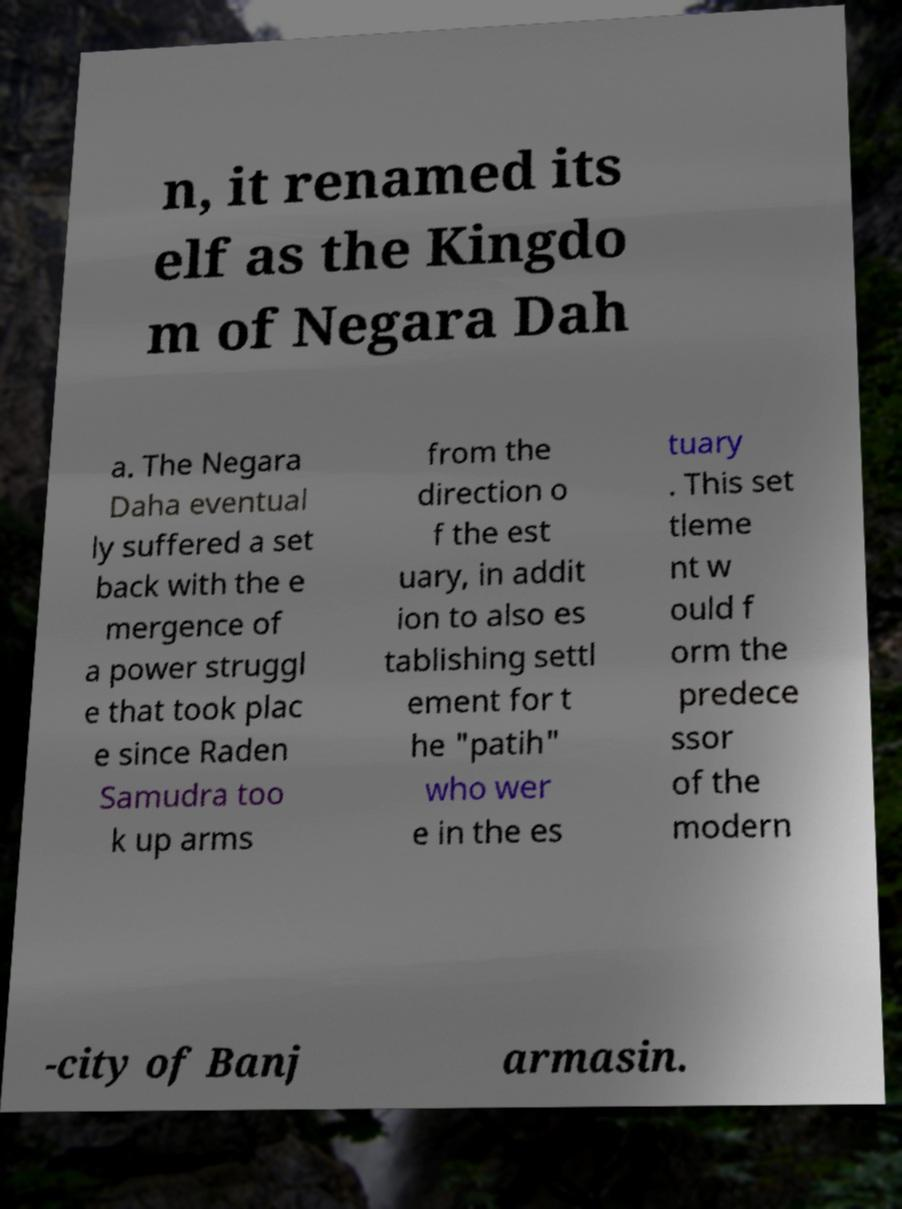I need the written content from this picture converted into text. Can you do that? n, it renamed its elf as the Kingdo m of Negara Dah a. The Negara Daha eventual ly suffered a set back with the e mergence of a power struggl e that took plac e since Raden Samudra too k up arms from the direction o f the est uary, in addit ion to also es tablishing settl ement for t he "patih" who wer e in the es tuary . This set tleme nt w ould f orm the predece ssor of the modern -city of Banj armasin. 